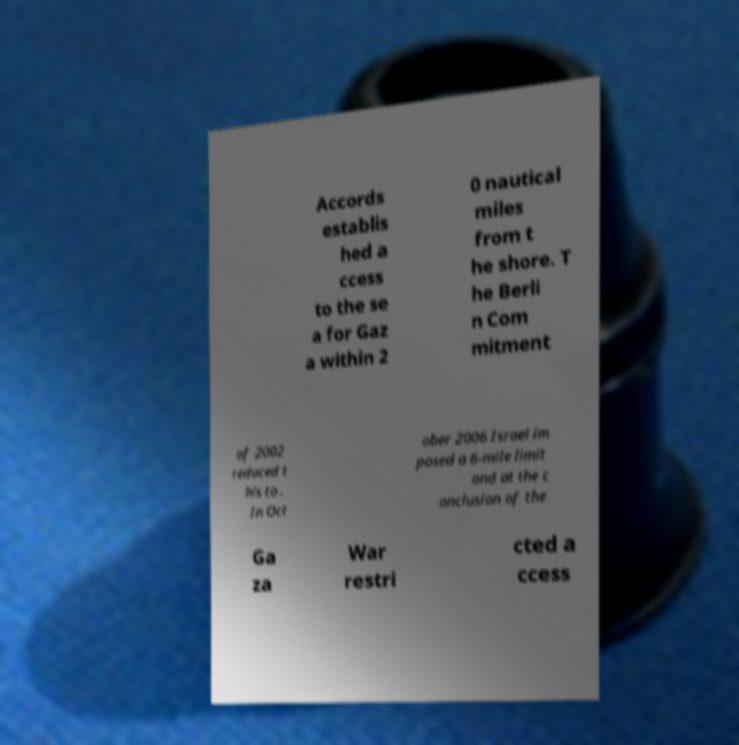Could you assist in decoding the text presented in this image and type it out clearly? Accords establis hed a ccess to the se a for Gaz a within 2 0 nautical miles from t he shore. T he Berli n Com mitment of 2002 reduced t his to . In Oct ober 2006 Israel im posed a 6-mile limit and at the c onclusion of the Ga za War restri cted a ccess 